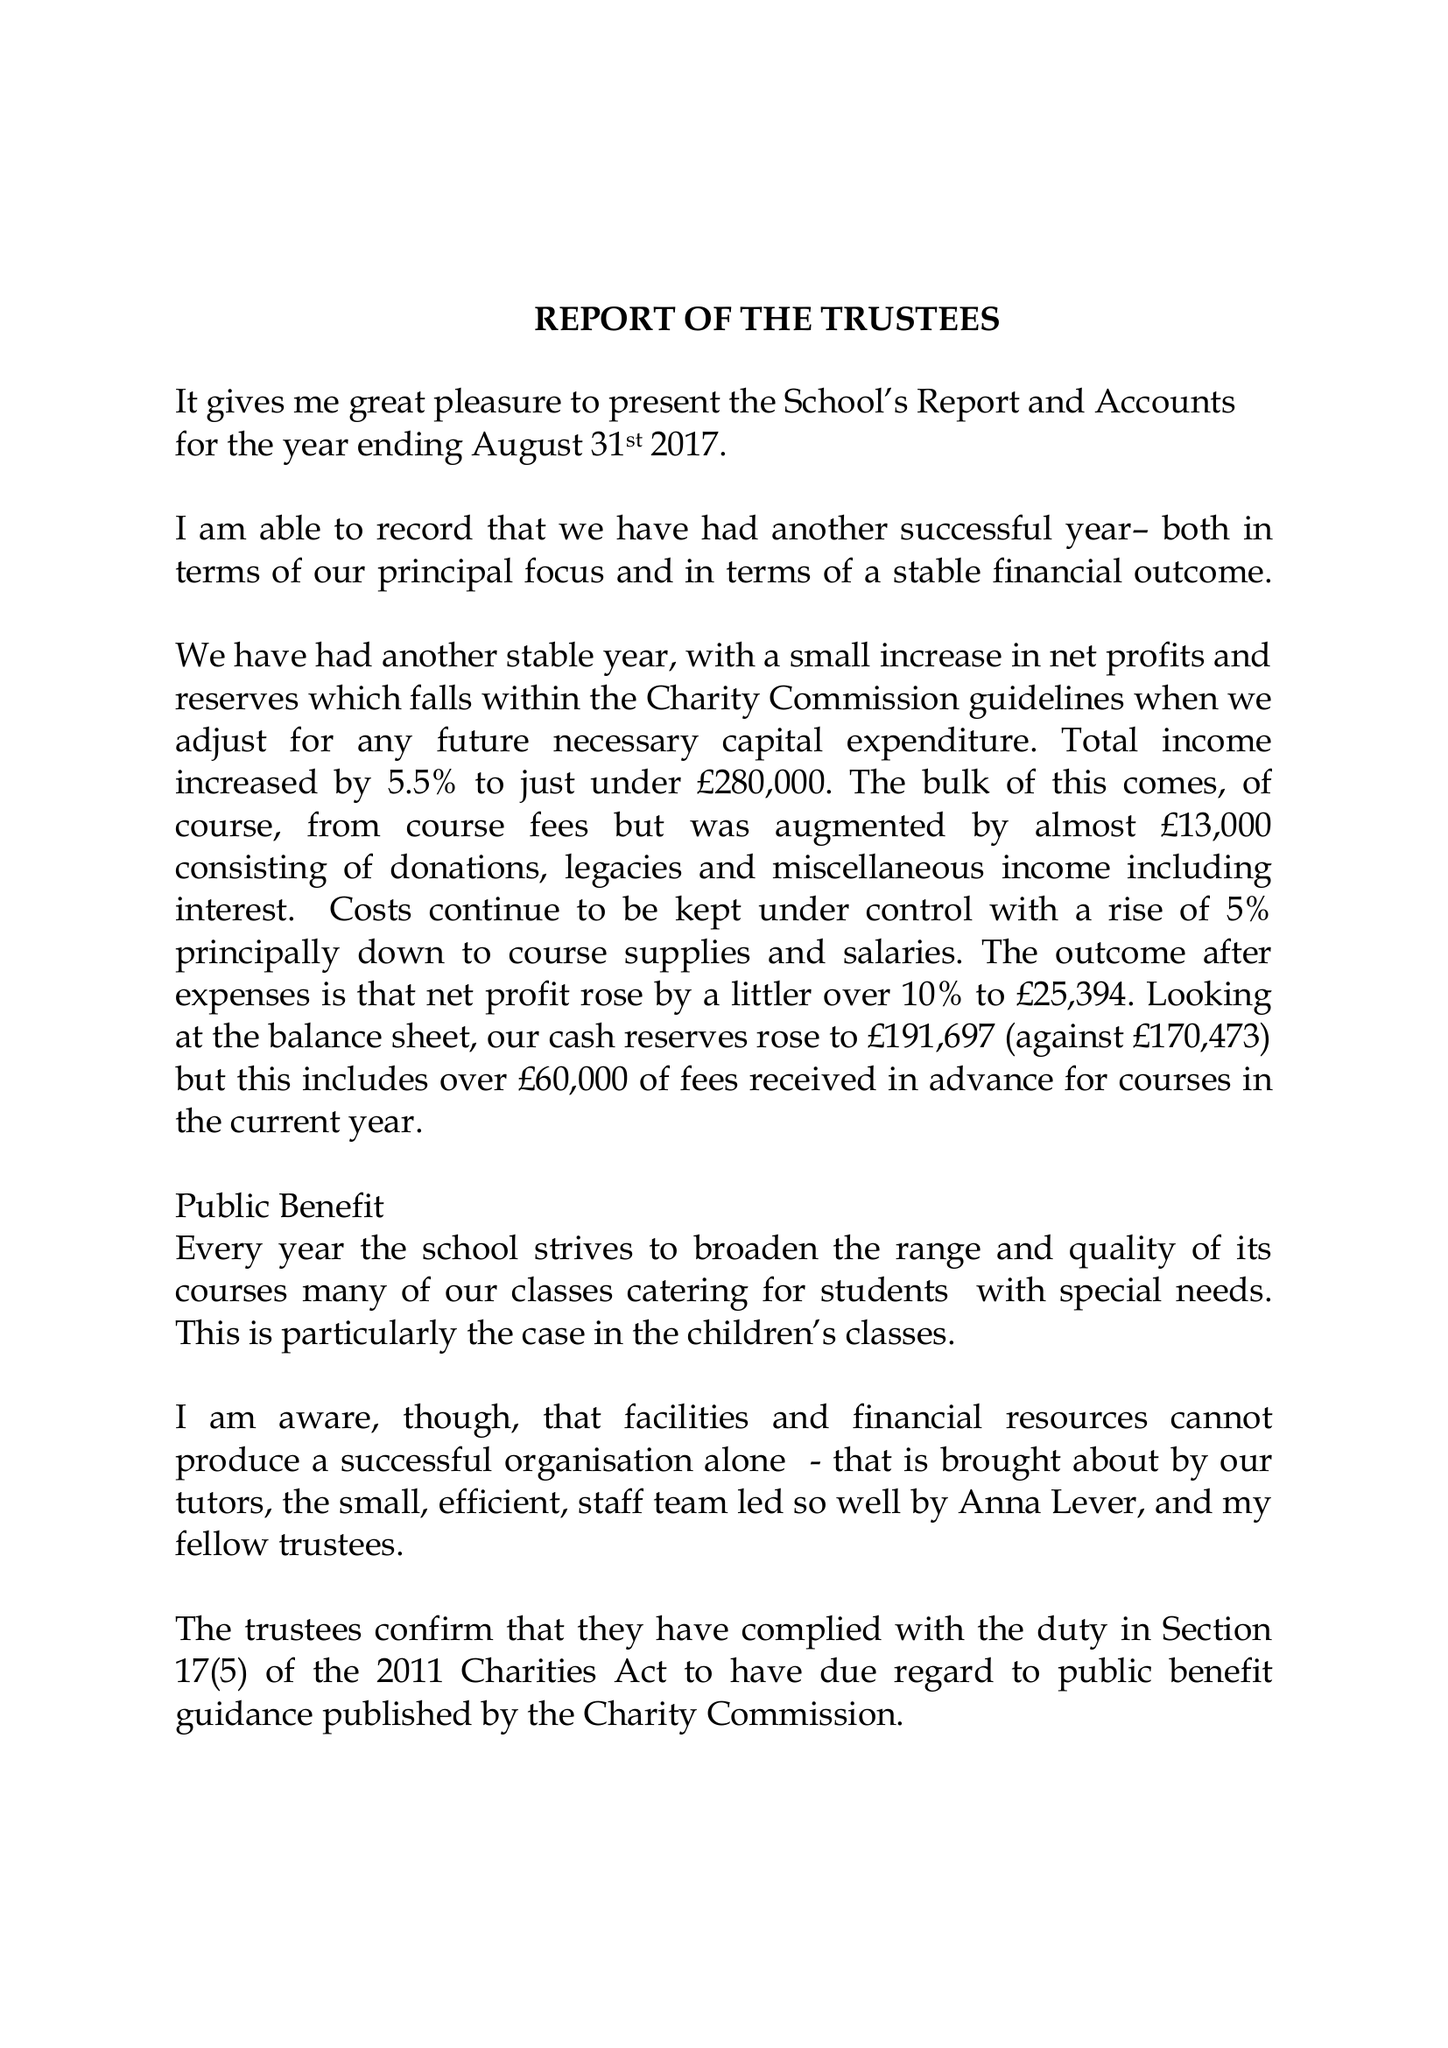What is the value for the spending_annually_in_british_pounds?
Answer the question using a single word or phrase. 254479.00 